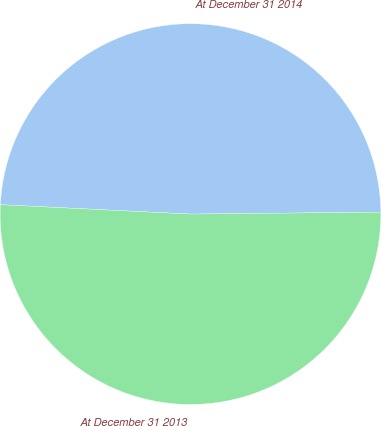Convert chart. <chart><loc_0><loc_0><loc_500><loc_500><pie_chart><fcel>At December 31 2014<fcel>At December 31 2013<nl><fcel>49.05%<fcel>50.95%<nl></chart> 